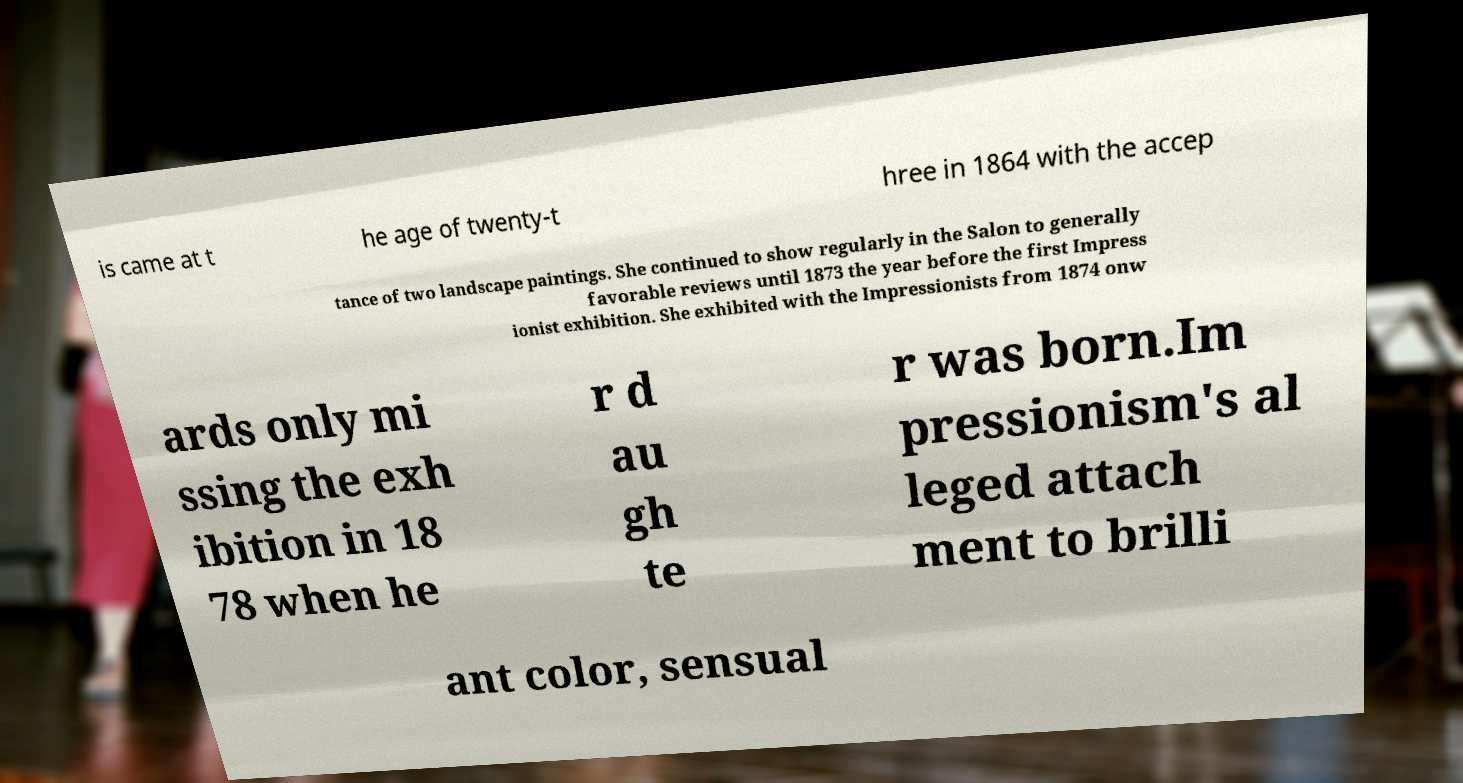For documentation purposes, I need the text within this image transcribed. Could you provide that? is came at t he age of twenty-t hree in 1864 with the accep tance of two landscape paintings. She continued to show regularly in the Salon to generally favorable reviews until 1873 the year before the first Impress ionist exhibition. She exhibited with the Impressionists from 1874 onw ards only mi ssing the exh ibition in 18 78 when he r d au gh te r was born.Im pressionism's al leged attach ment to brilli ant color, sensual 